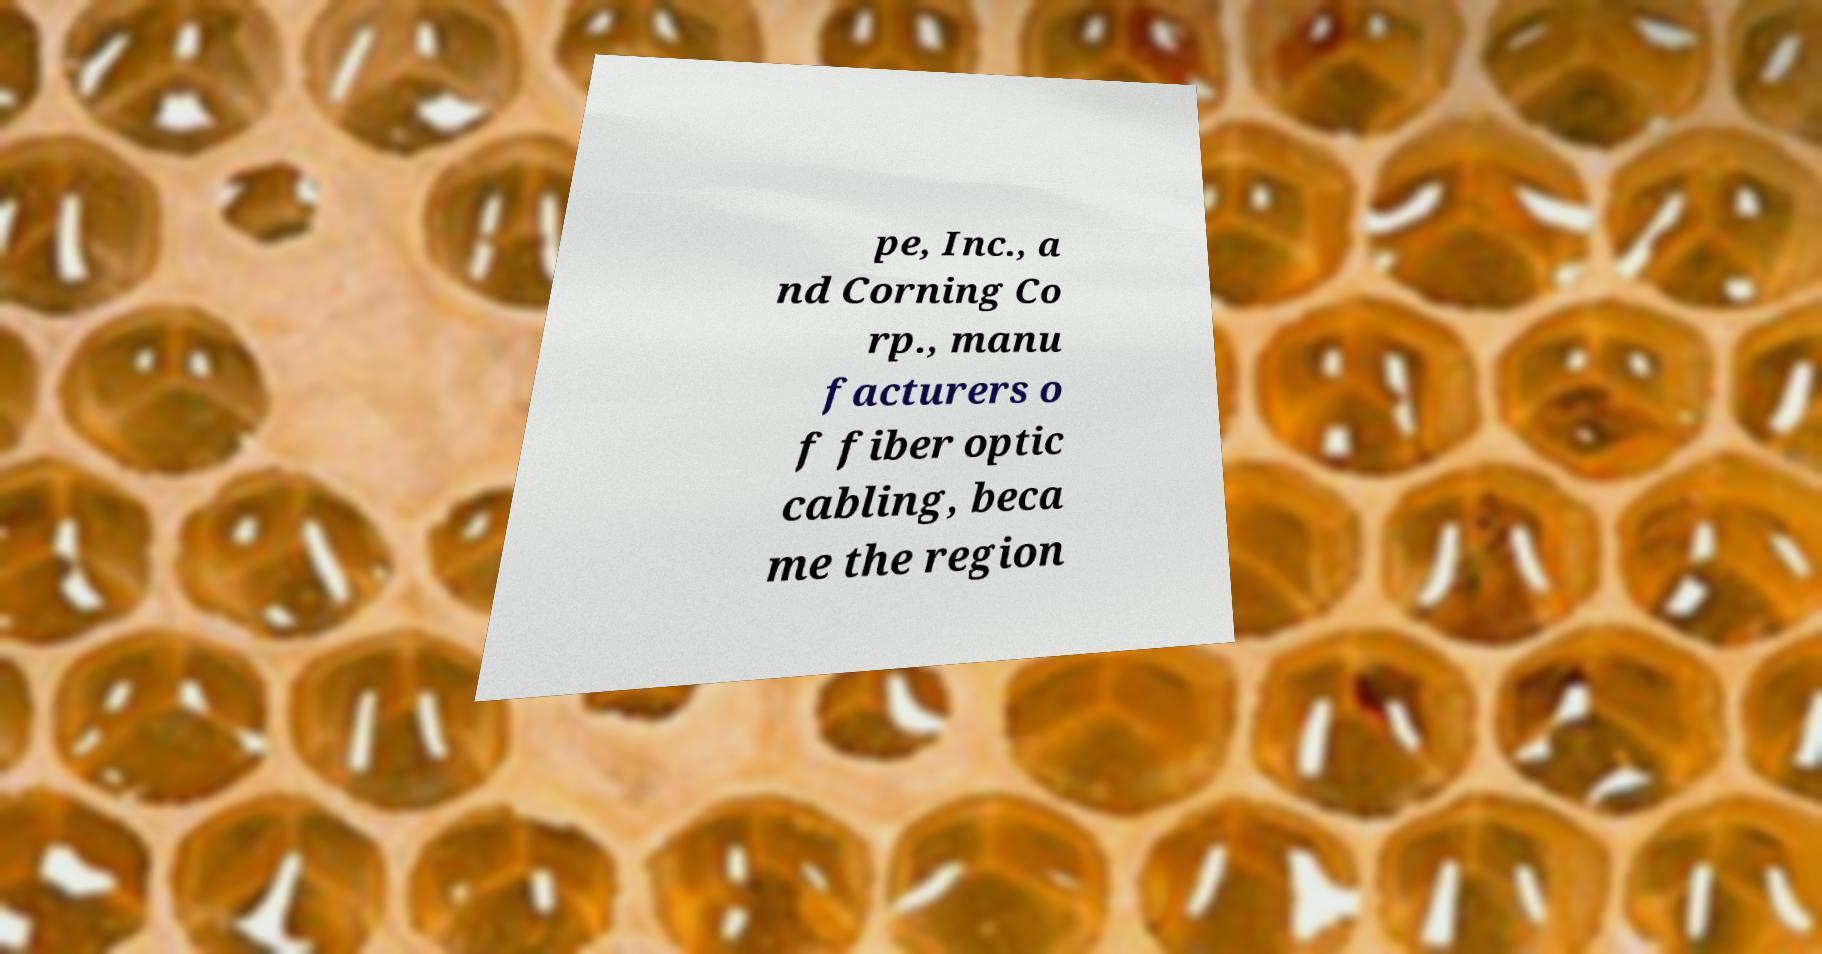I need the written content from this picture converted into text. Can you do that? pe, Inc., a nd Corning Co rp., manu facturers o f fiber optic cabling, beca me the region 